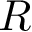<formula> <loc_0><loc_0><loc_500><loc_500>R</formula> 